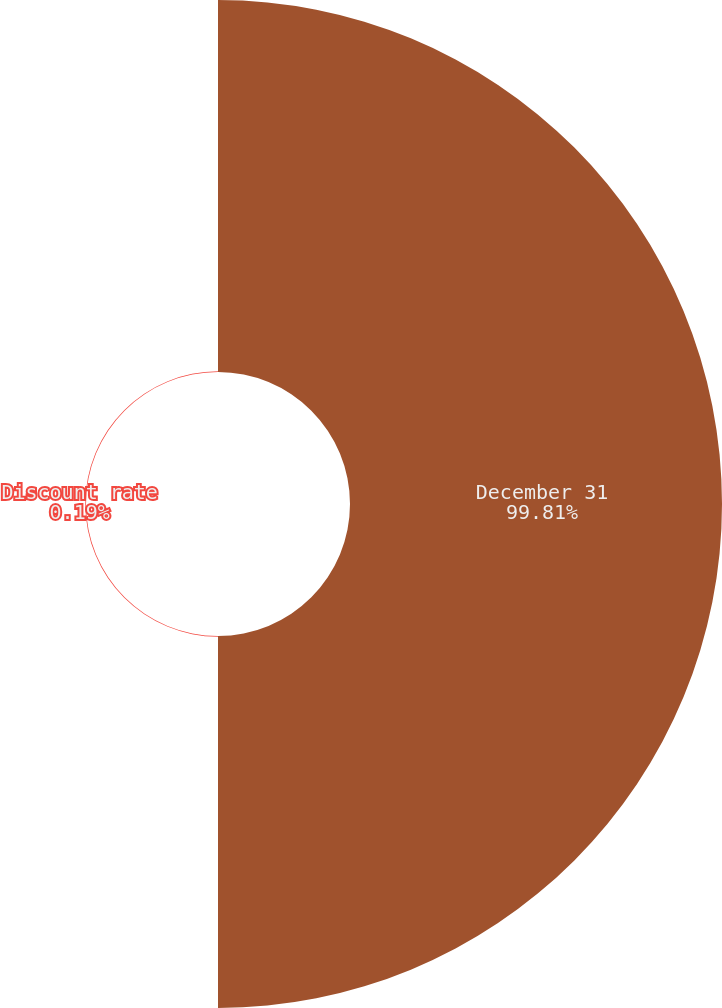<chart> <loc_0><loc_0><loc_500><loc_500><pie_chart><fcel>December 31<fcel>Discount rate<nl><fcel>99.81%<fcel>0.19%<nl></chart> 